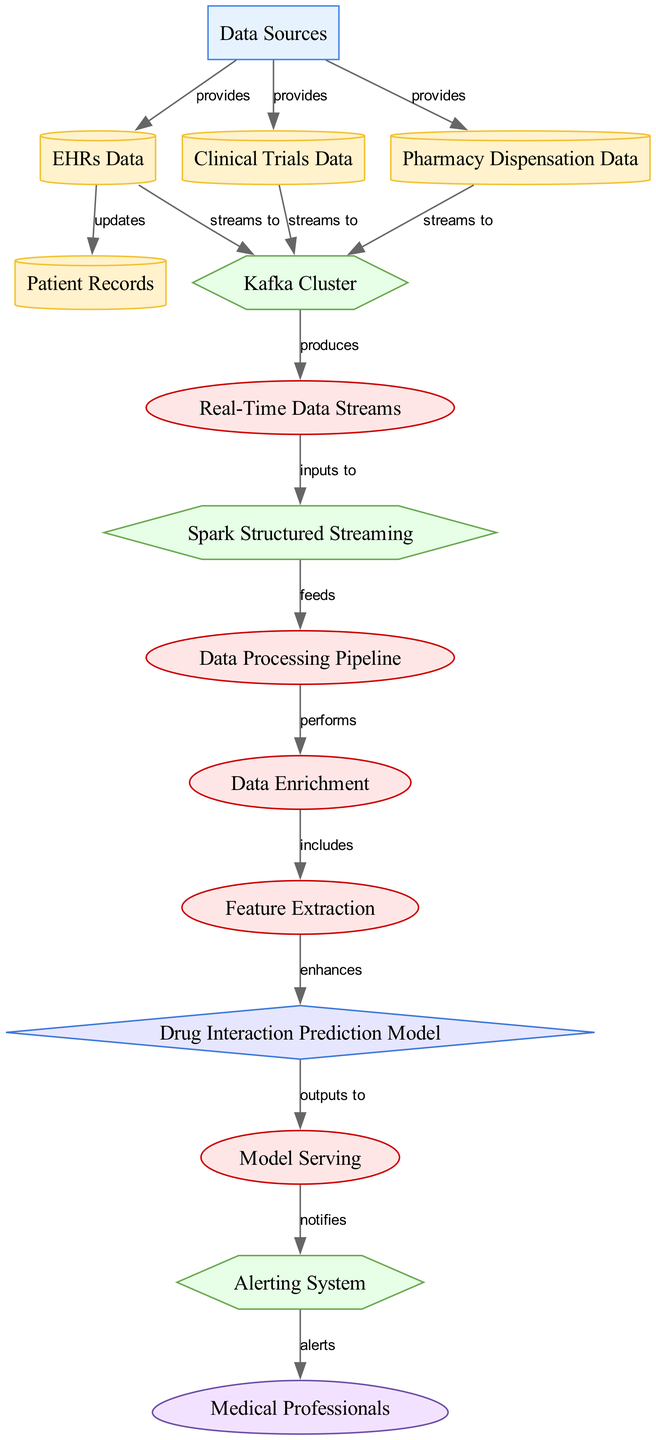What are the three data sources mentioned in the diagram? The diagram lists three data sources: EHRs Data, Clinical Trials Data, and Pharmacy Dispensation Data, connected to the Data Sources node.
Answer: EHRs Data, Clinical Trials Data, Pharmacy Dispensation Data How many processes are depicted in the diagram? The diagram includes five processes: Real-Time Data Streams, Data Processing Pipeline, Data Enrichment, Feature Extraction, and Model Serving. Counting these nodes shows there are five distinct processes.
Answer: Five What technology is used for data streaming? The data streaming technology mentioned in the diagram is the Kafka Cluster, which receives data from multiple sources and produces data streams.
Answer: Kafka Cluster Which node notifies the alerting system? The Model Serving node is responsible for outputting notifications to the Alerting System, as shown by the outgoing edge labeled "notifies."
Answer: Model Serving What is the input to Spark Structured Streaming? The input to Spark Structured Streaming is the Real-Time Data Streams produced by the Kafka Cluster. This can be traced through the directed edges in the diagram leading from the streams to Spark Structured Streaming.
Answer: Real-Time Data Streams How does patient records get updated? Patient Records are updated through the EHRs Data node, as there's a directed edge from EHRs Data to Patient Records labeled "updates," indicating that data flows from EHRs to Patient Records.
Answer: EHRs Data Which process comes after Data Enrichment? After Data Enrichment, the next process is Feature Extraction, as demonstrated by the directed edge labeled "includes" flowing from Data Enrichment to Feature Extraction.
Answer: Feature Extraction Who receives the alerts from the alerting system? The recipients of the alerts from the Alerting System are Medical Professionals, as indicated by the edge labeled "alerts" that goes from Alerting System to Medical Professionals.
Answer: Medical Professionals What role does the Drug Interaction Prediction Model play in the diagram? The Drug Interaction Prediction Model enhances the output from Feature Extraction and serves as an analytic component, thus contributing to the overall data processing workflow. This can be seen through the directed edge labeled "enhances."
Answer: Drug Interaction Prediction Model 